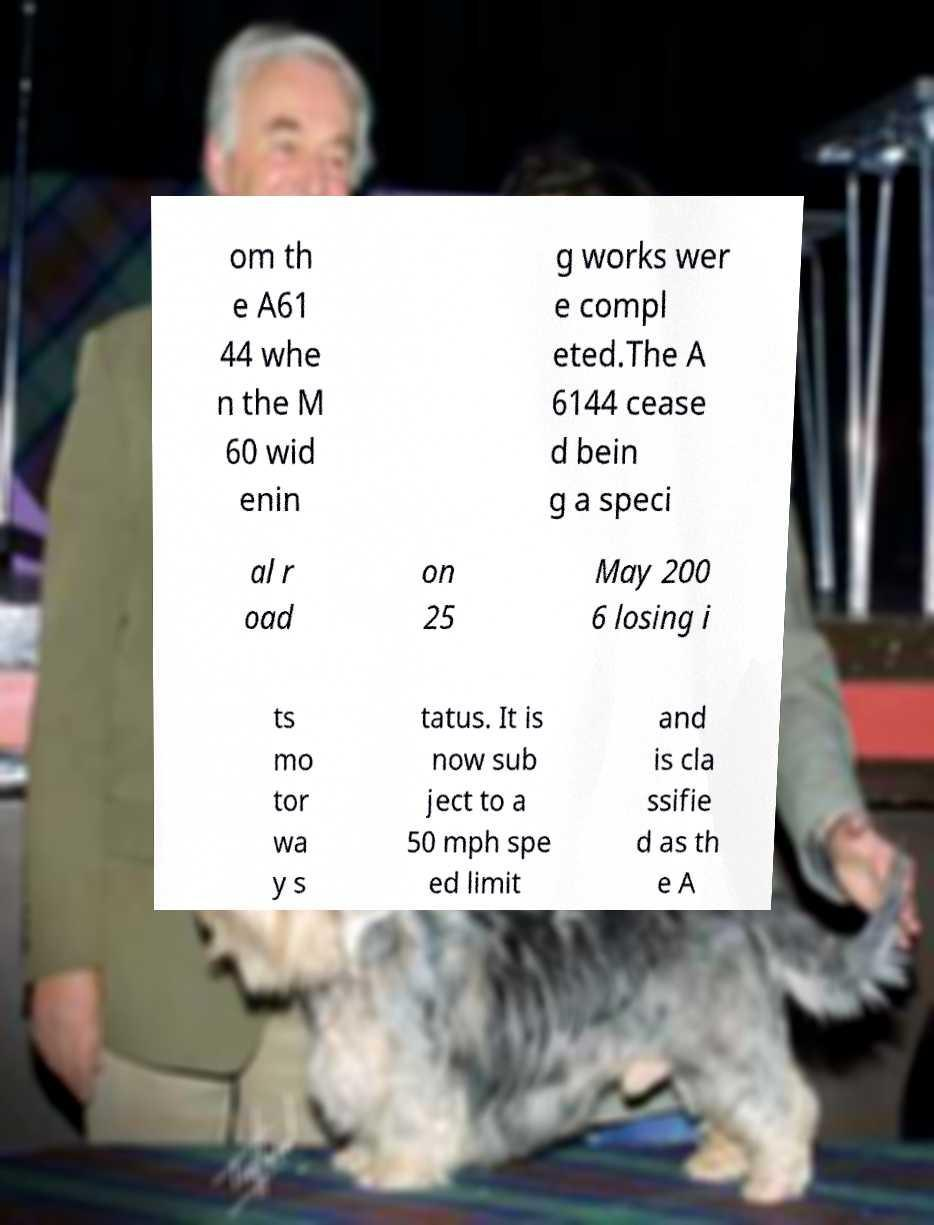For documentation purposes, I need the text within this image transcribed. Could you provide that? om th e A61 44 whe n the M 60 wid enin g works wer e compl eted.The A 6144 cease d bein g a speci al r oad on 25 May 200 6 losing i ts mo tor wa y s tatus. It is now sub ject to a 50 mph spe ed limit and is cla ssifie d as th e A 